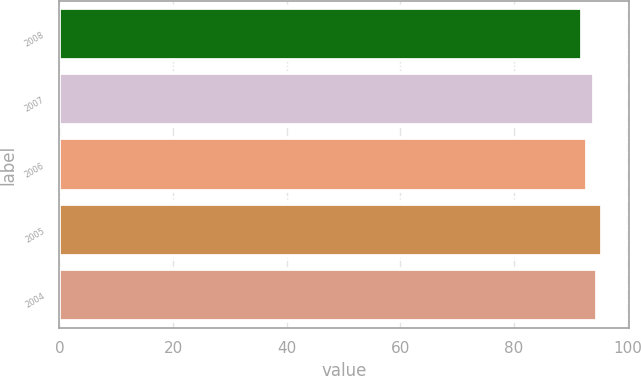<chart> <loc_0><loc_0><loc_500><loc_500><bar_chart><fcel>2008<fcel>2007<fcel>2006<fcel>2005<fcel>2004<nl><fcel>91.9<fcel>94.1<fcel>92.9<fcel>95.5<fcel>94.5<nl></chart> 